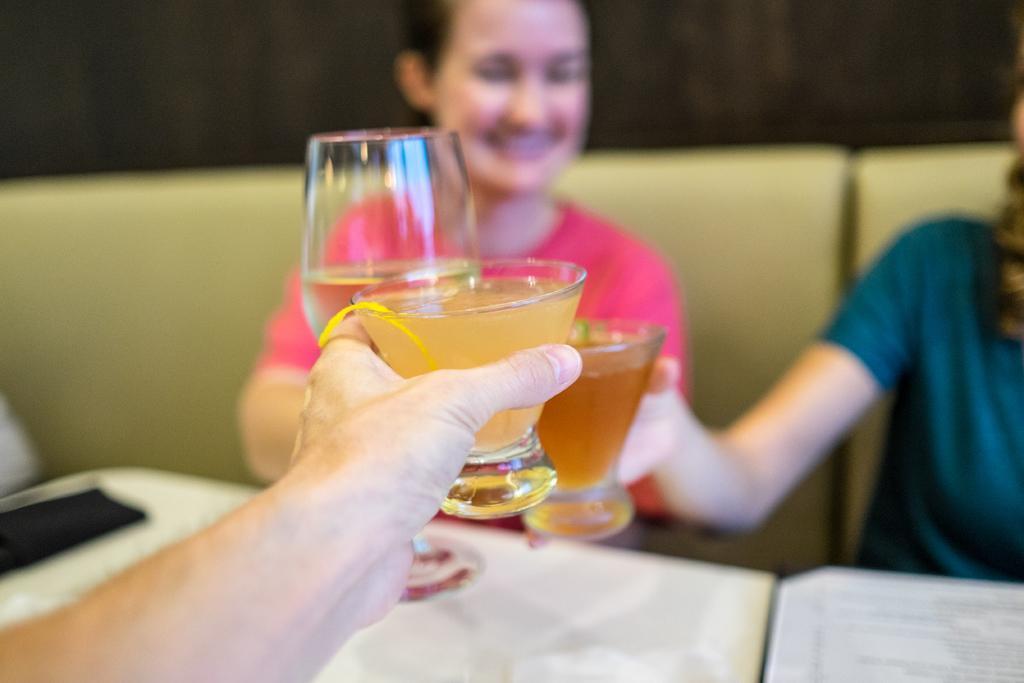Can you describe this image briefly? In this picture we can see people sitting in a couch, in front we can see the table, they are holding glasses. 